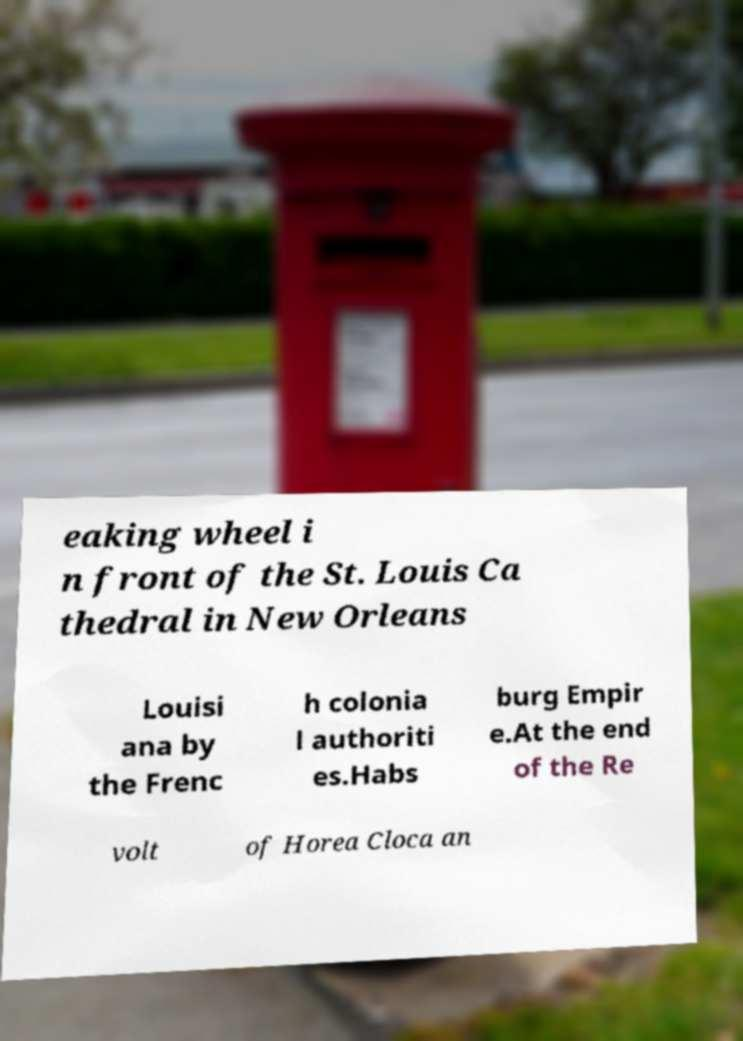Could you assist in decoding the text presented in this image and type it out clearly? eaking wheel i n front of the St. Louis Ca thedral in New Orleans Louisi ana by the Frenc h colonia l authoriti es.Habs burg Empir e.At the end of the Re volt of Horea Cloca an 